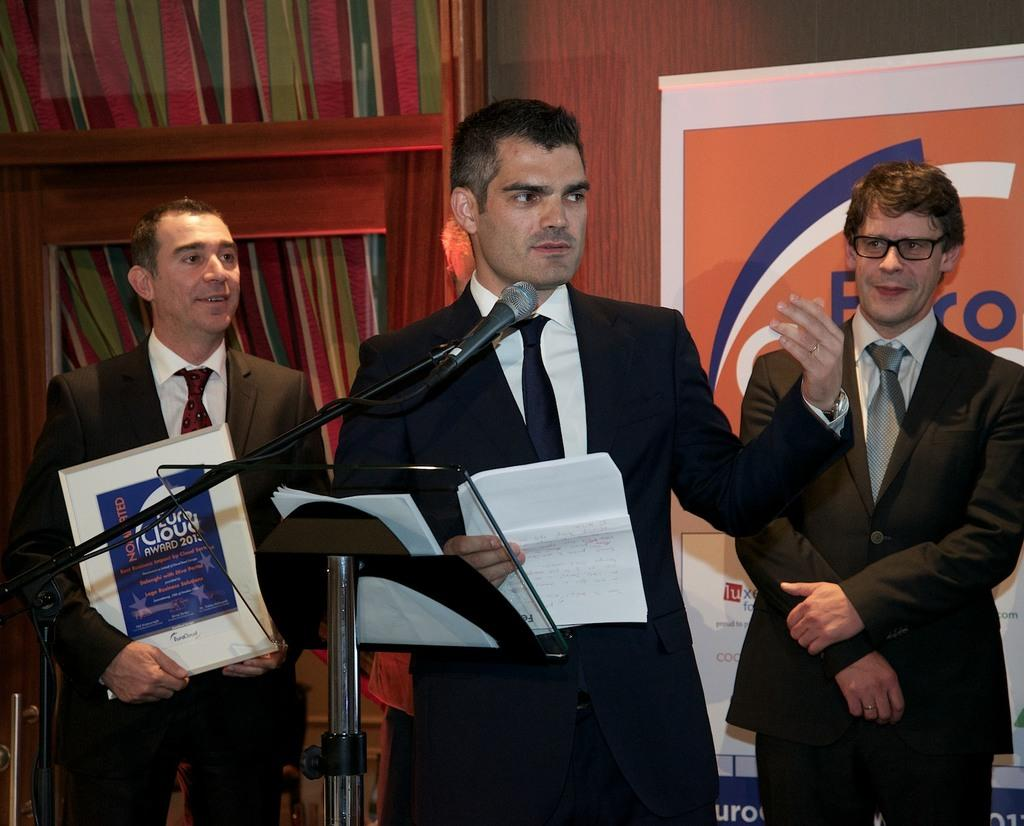How many people are in the image? There are three people in the image. What object is present in the image that is typically used for amplifying sound? There is a microphone (mike) in the image. What type of background can be seen in the image? There is a wooden background in the image. What type of invention is the grandfather holding in the image? There is no grandfather or invention present in the image. What type of wire is visible in the image? There is no wire visible in the image. 